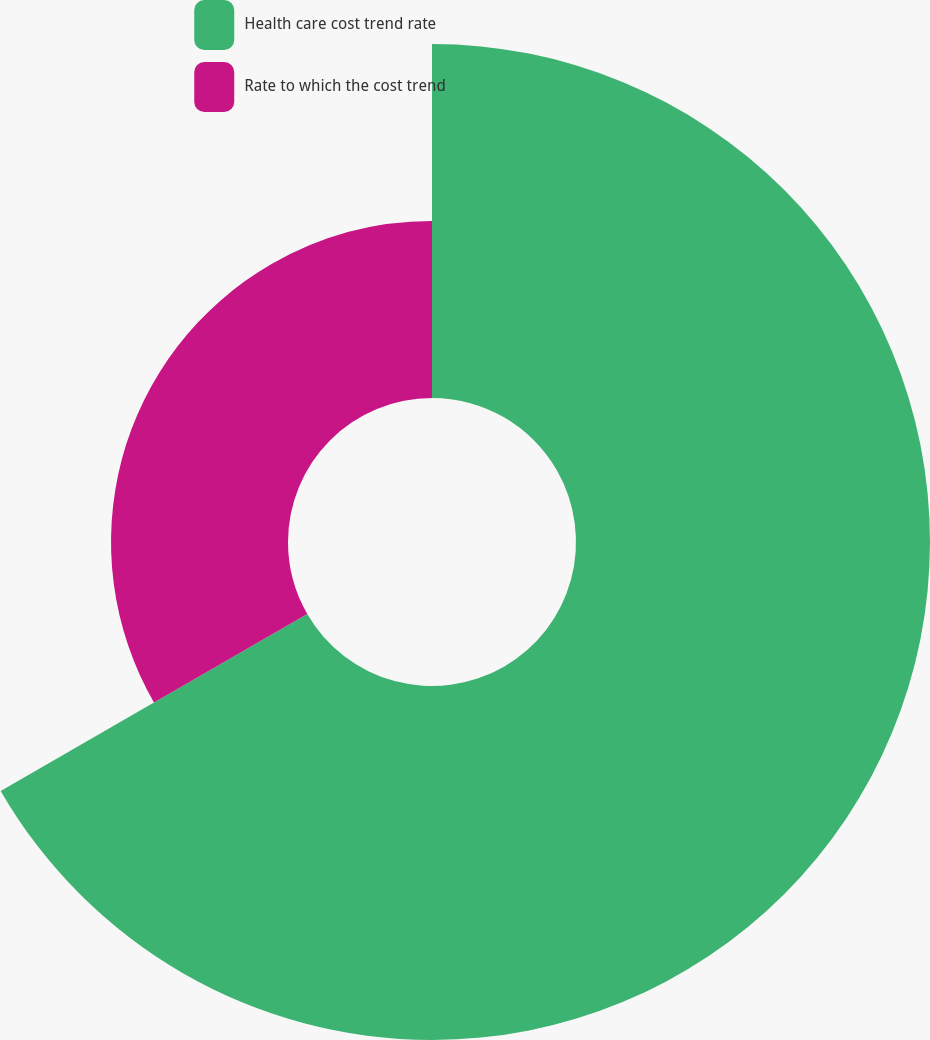<chart> <loc_0><loc_0><loc_500><loc_500><pie_chart><fcel>Health care cost trend rate<fcel>Rate to which the cost trend<nl><fcel>66.67%<fcel>33.33%<nl></chart> 